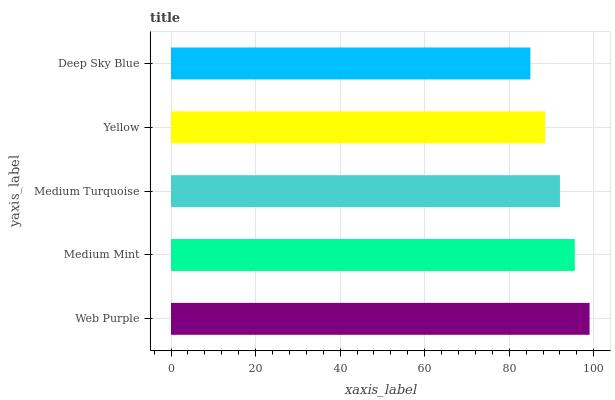Is Deep Sky Blue the minimum?
Answer yes or no. Yes. Is Web Purple the maximum?
Answer yes or no. Yes. Is Medium Mint the minimum?
Answer yes or no. No. Is Medium Mint the maximum?
Answer yes or no. No. Is Web Purple greater than Medium Mint?
Answer yes or no. Yes. Is Medium Mint less than Web Purple?
Answer yes or no. Yes. Is Medium Mint greater than Web Purple?
Answer yes or no. No. Is Web Purple less than Medium Mint?
Answer yes or no. No. Is Medium Turquoise the high median?
Answer yes or no. Yes. Is Medium Turquoise the low median?
Answer yes or no. Yes. Is Deep Sky Blue the high median?
Answer yes or no. No. Is Medium Mint the low median?
Answer yes or no. No. 